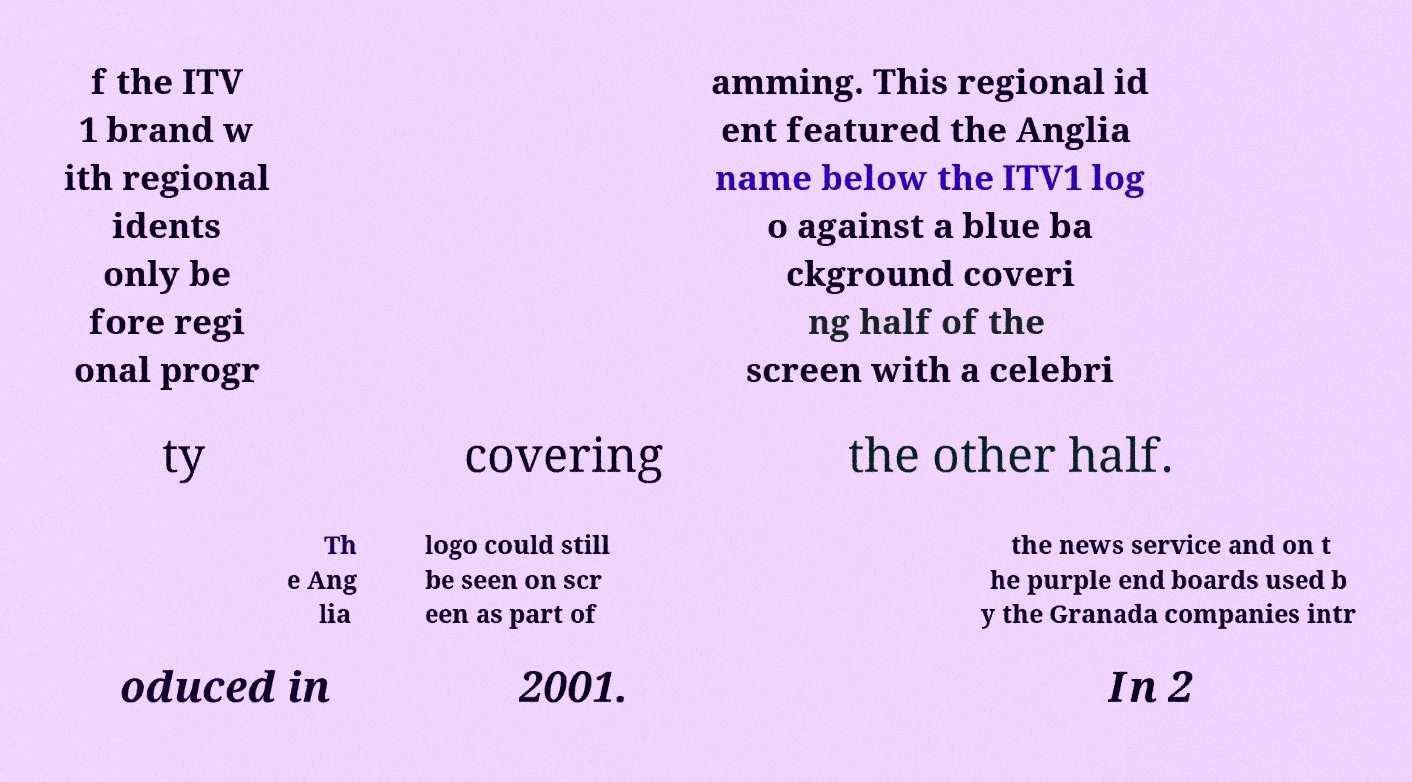Please identify and transcribe the text found in this image. f the ITV 1 brand w ith regional idents only be fore regi onal progr amming. This regional id ent featured the Anglia name below the ITV1 log o against a blue ba ckground coveri ng half of the screen with a celebri ty covering the other half. Th e Ang lia logo could still be seen on scr een as part of the news service and on t he purple end boards used b y the Granada companies intr oduced in 2001. In 2 